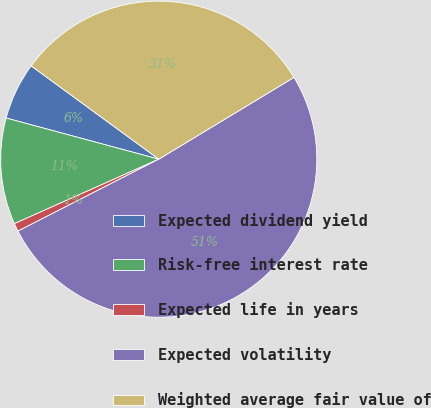Convert chart. <chart><loc_0><loc_0><loc_500><loc_500><pie_chart><fcel>Expected dividend yield<fcel>Risk-free interest rate<fcel>Expected life in years<fcel>Expected volatility<fcel>Weighted average fair value of<nl><fcel>5.86%<fcel>10.88%<fcel>0.83%<fcel>51.14%<fcel>31.29%<nl></chart> 